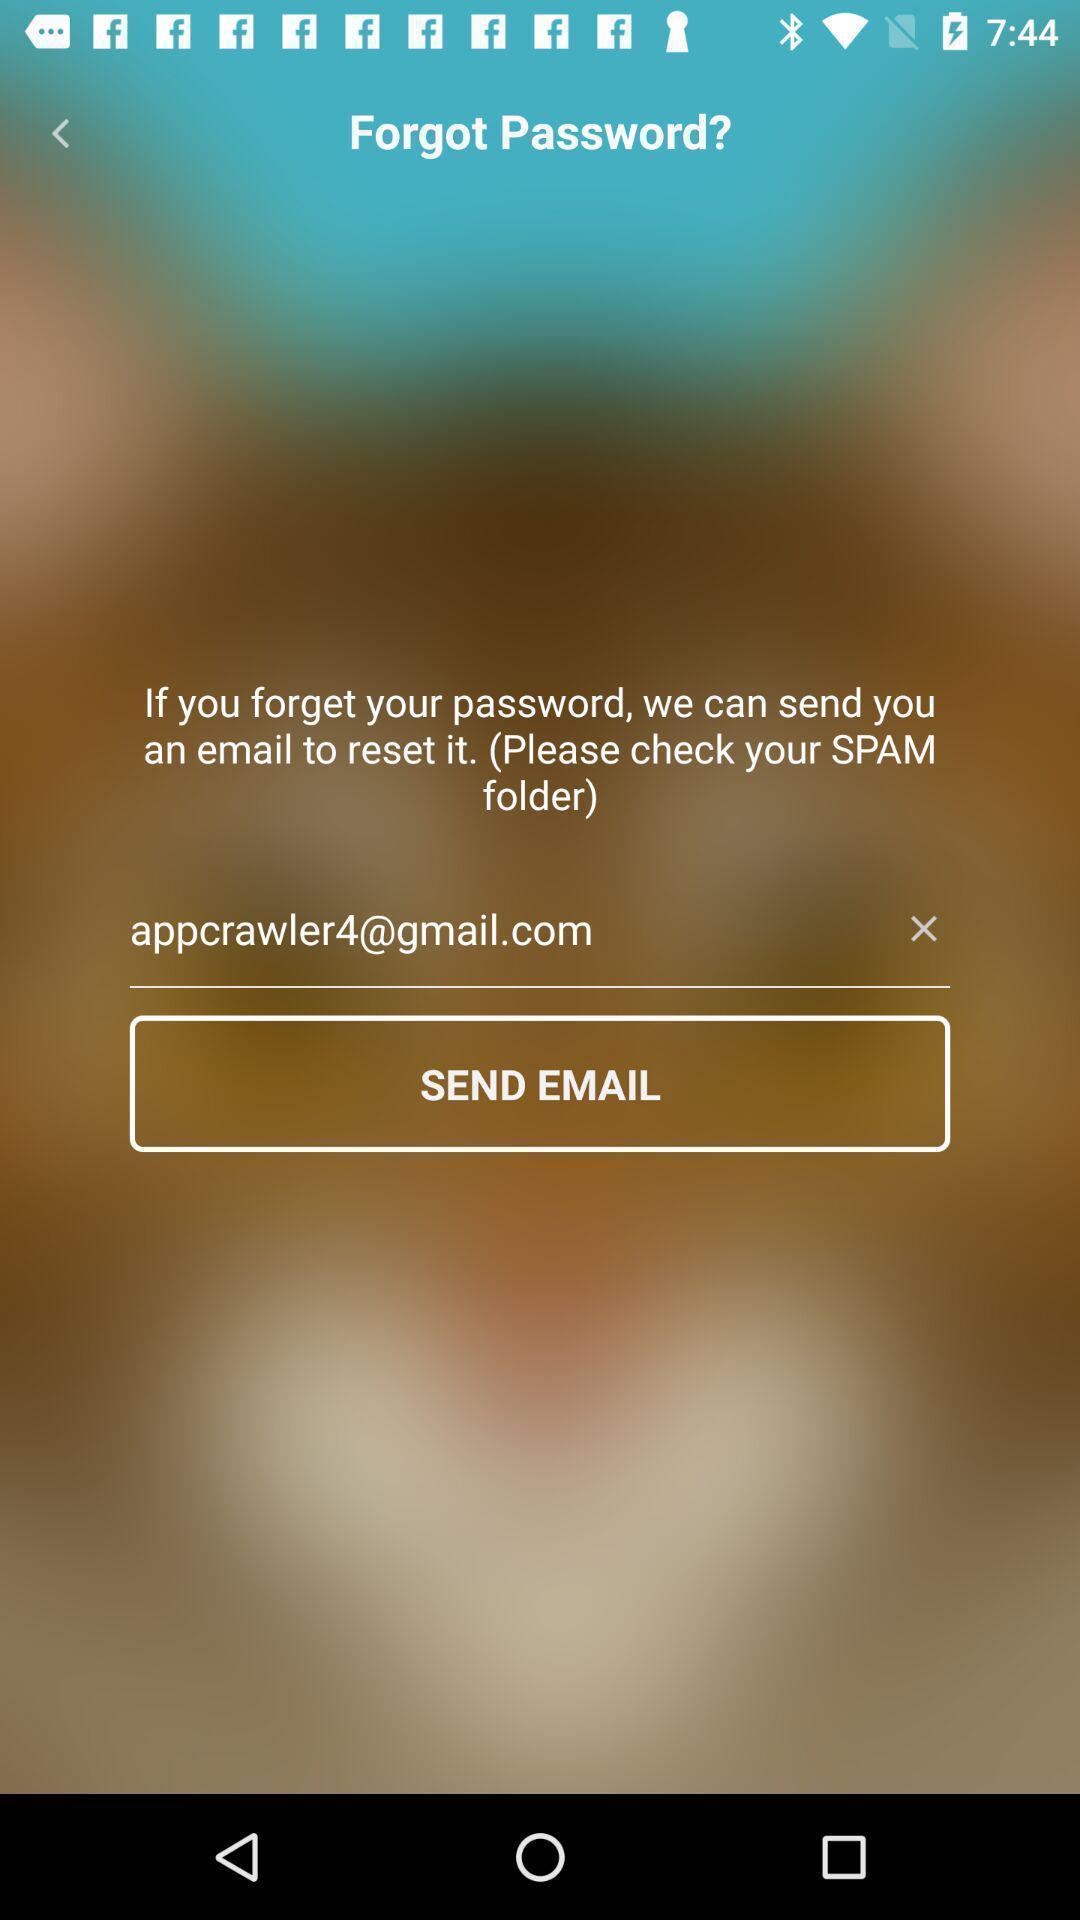Describe this image in words. Screen displaying user email credentials. 